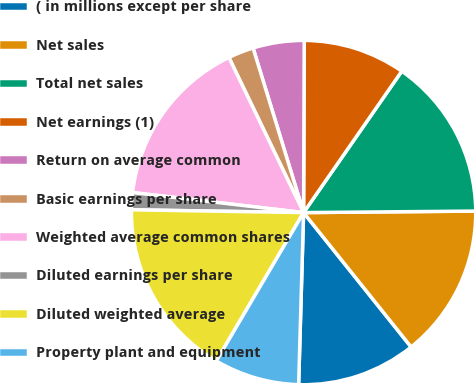Convert chart to OTSL. <chart><loc_0><loc_0><loc_500><loc_500><pie_chart><fcel>( in millions except per share<fcel>Net sales<fcel>Total net sales<fcel>Net earnings (1)<fcel>Return on average common<fcel>Basic earnings per share<fcel>Weighted average common shares<fcel>Diluted earnings per share<fcel>Diluted weighted average<fcel>Property plant and equipment<nl><fcel>11.2%<fcel>14.4%<fcel>15.2%<fcel>9.6%<fcel>4.8%<fcel>2.4%<fcel>16.0%<fcel>1.6%<fcel>16.8%<fcel>8.0%<nl></chart> 